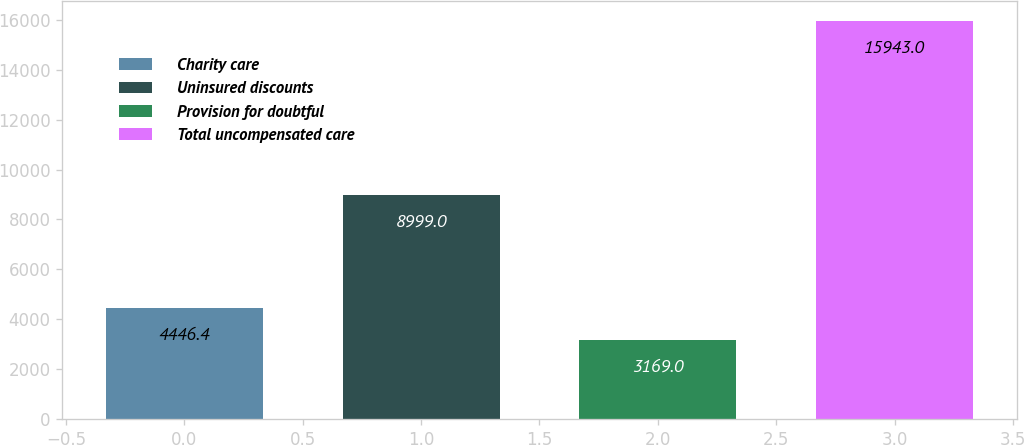Convert chart. <chart><loc_0><loc_0><loc_500><loc_500><bar_chart><fcel>Charity care<fcel>Uninsured discounts<fcel>Provision for doubtful<fcel>Total uncompensated care<nl><fcel>4446.4<fcel>8999<fcel>3169<fcel>15943<nl></chart> 